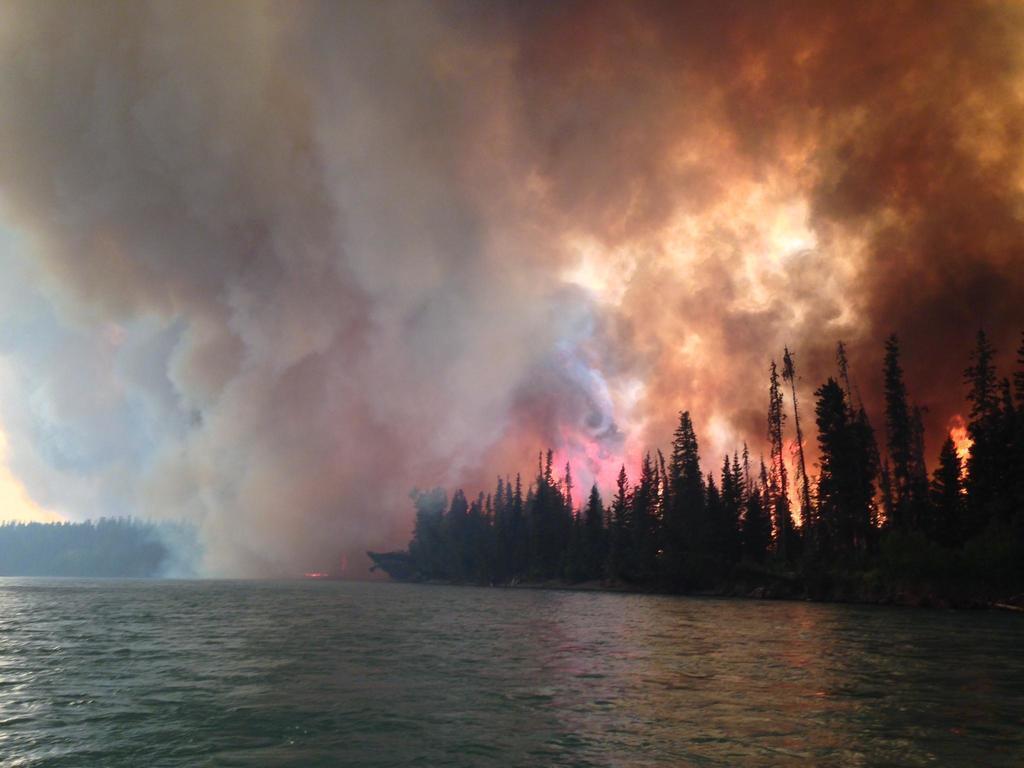How would you summarize this image in a sentence or two? In this picture we can see fire in the forest. On the bottom we can see river. On the right we can see many trees. Here it's a sky. On the top we can see smoke. 